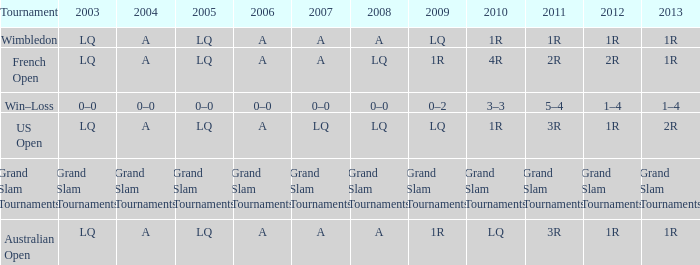Which year has a 2003 of lq? 1R, 1R, LQ, LQ. 